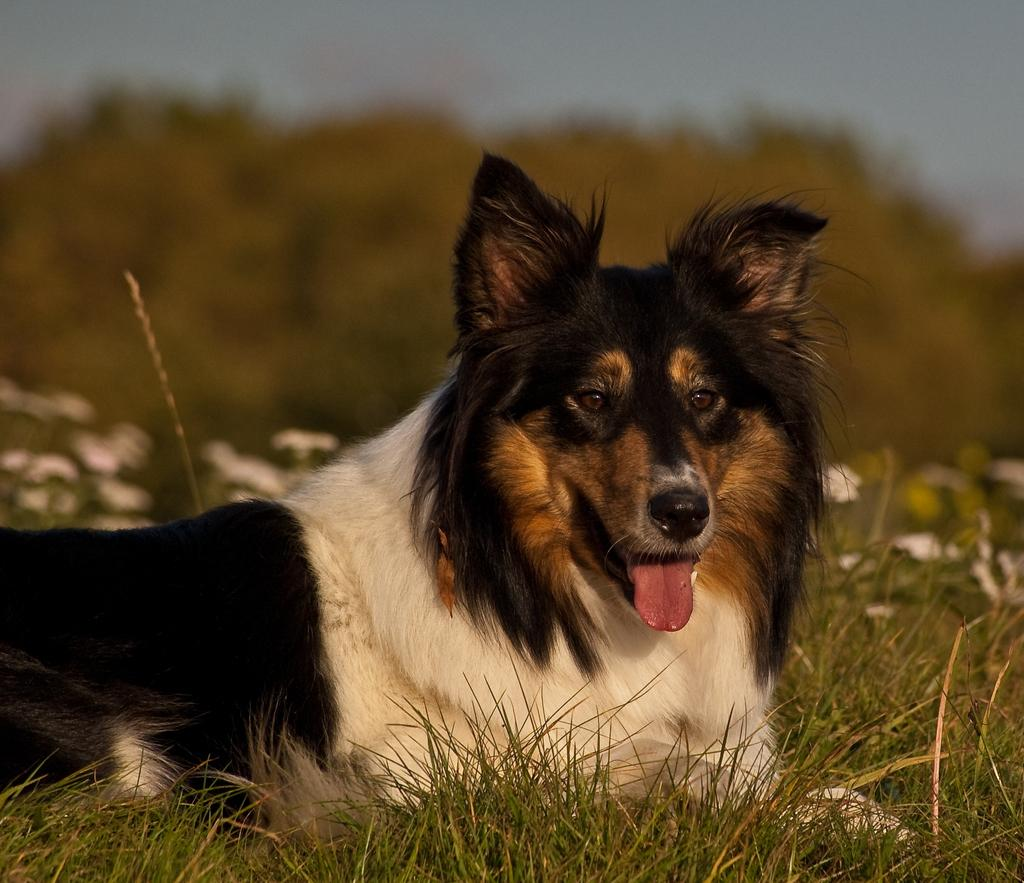What animal can be seen in the image? There is a dog in the image. Where is the dog located? The dog is on the grass. What can be seen in the background of the image? The background of the image is blurred, but plants, flowers, trees, and the sky are visible. What month is it in the image? The month cannot be determined from the image, as there is no information about the time of year. Can you tell me how many fields are visible in the image? There is no field visible in the image; it features a dog on the grass, plants, flowers, trees, and the sky. 